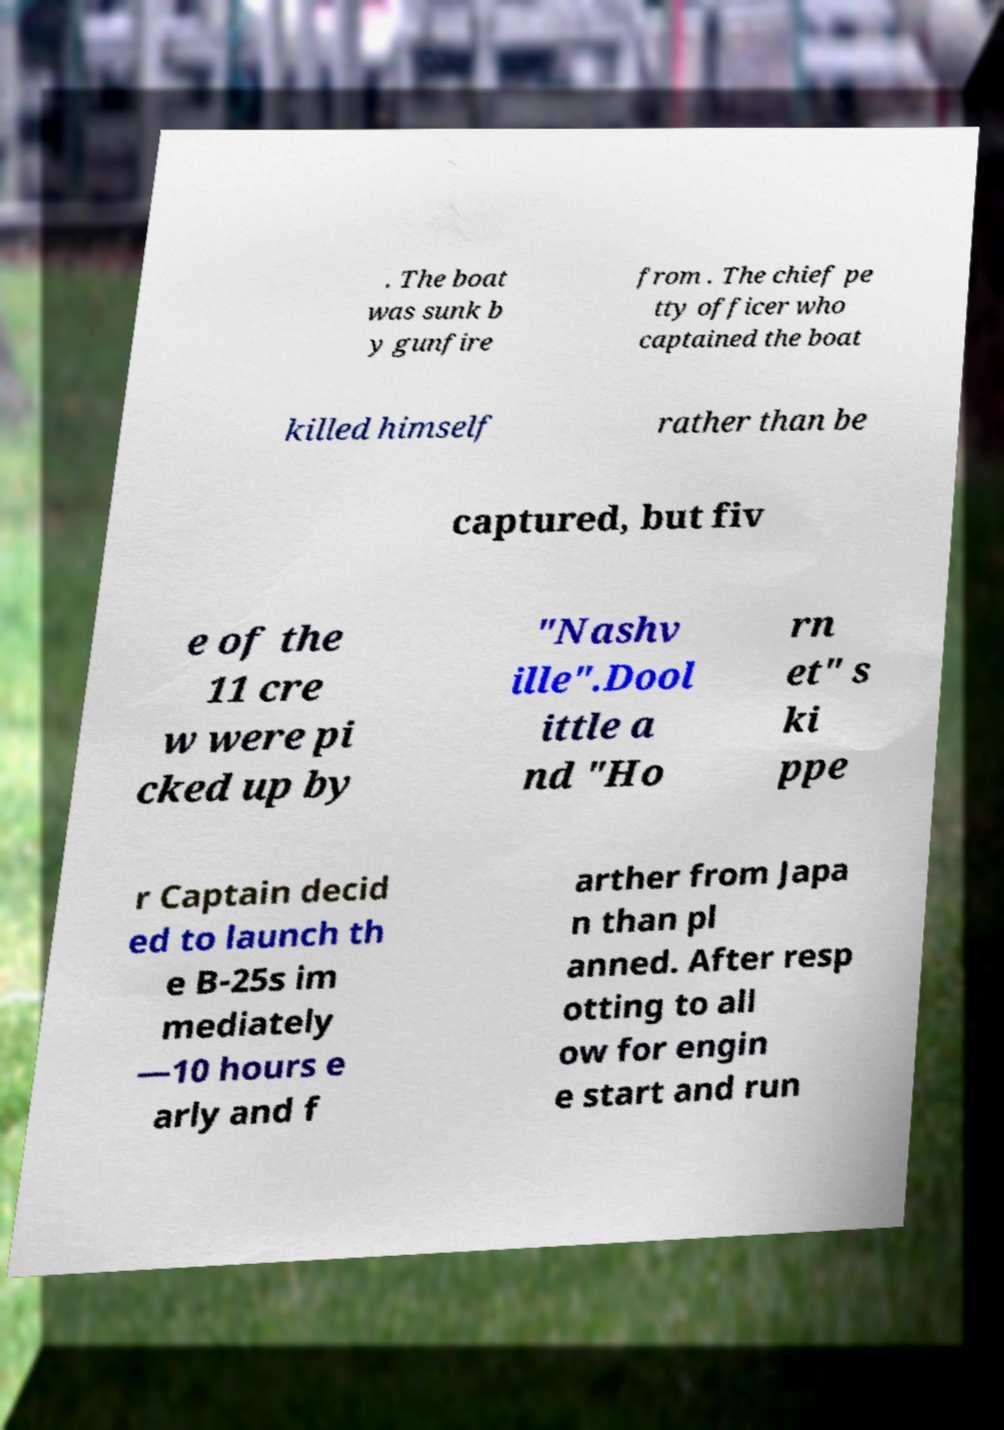Can you read and provide the text displayed in the image?This photo seems to have some interesting text. Can you extract and type it out for me? . The boat was sunk b y gunfire from . The chief pe tty officer who captained the boat killed himself rather than be captured, but fiv e of the 11 cre w were pi cked up by "Nashv ille".Dool ittle a nd "Ho rn et" s ki ppe r Captain decid ed to launch th e B-25s im mediately —10 hours e arly and f arther from Japa n than pl anned. After resp otting to all ow for engin e start and run 